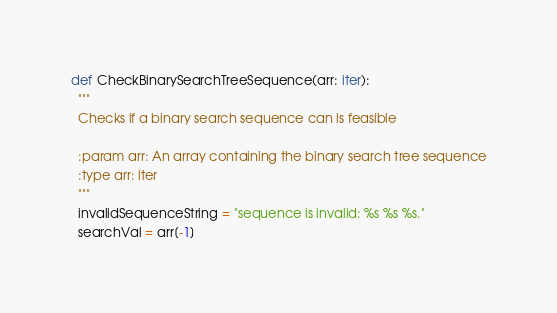Convert code to text. <code><loc_0><loc_0><loc_500><loc_500><_Python_>def CheckBinarySearchTreeSequence(arr: iter):
  """
  Checks if a binary search sequence can is feasible
  
  :param arr: An array containing the binary search tree sequence
  :type arr: iter
  """
  invalidSequenceString = "sequence is invalid: %s %s %s."
  searchVal = arr[-1]</code> 